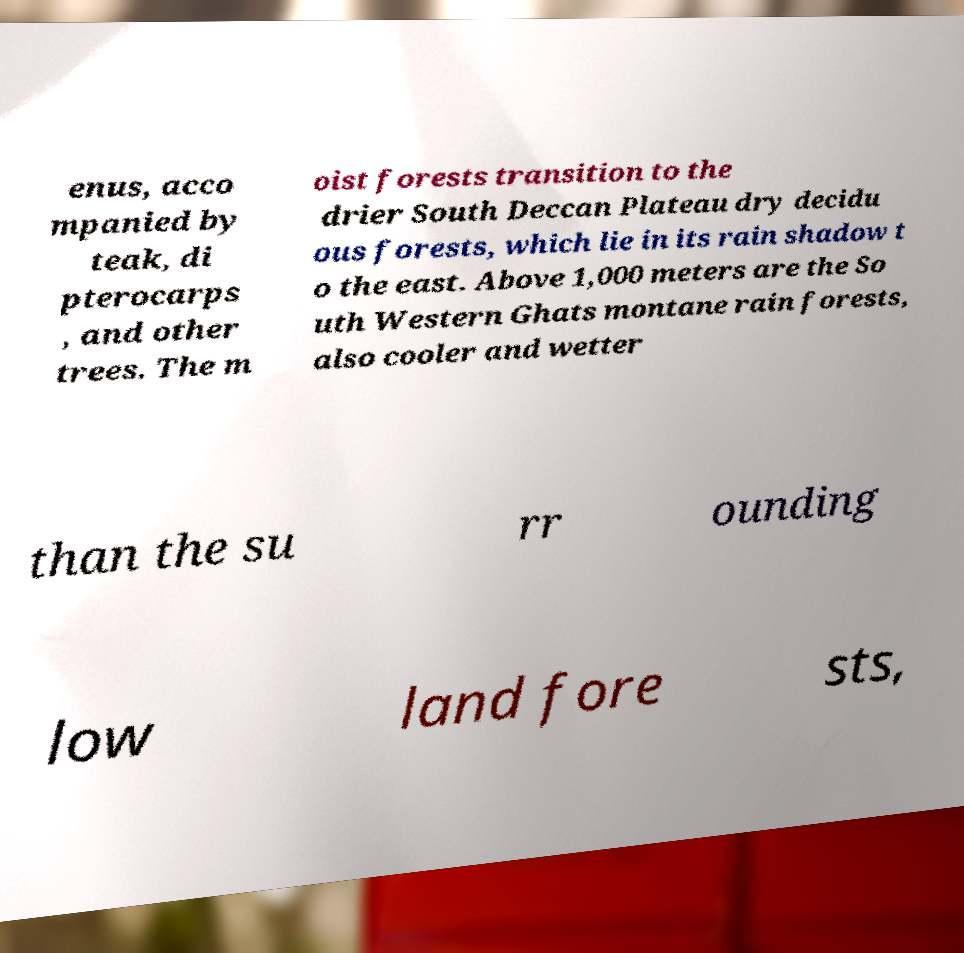Could you assist in decoding the text presented in this image and type it out clearly? enus, acco mpanied by teak, di pterocarps , and other trees. The m oist forests transition to the drier South Deccan Plateau dry decidu ous forests, which lie in its rain shadow t o the east. Above 1,000 meters are the So uth Western Ghats montane rain forests, also cooler and wetter than the su rr ounding low land fore sts, 